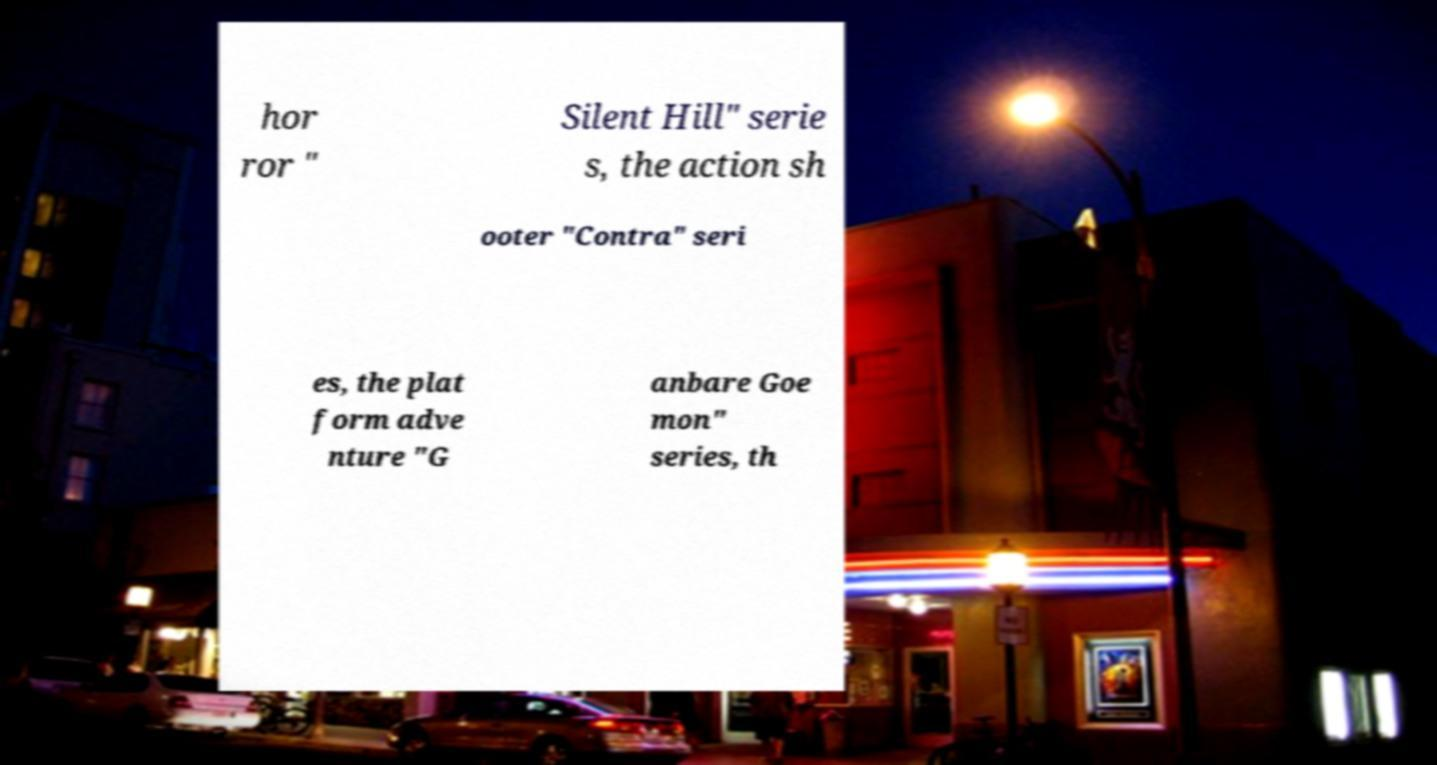Please read and relay the text visible in this image. What does it say? hor ror " Silent Hill" serie s, the action sh ooter "Contra" seri es, the plat form adve nture "G anbare Goe mon" series, th 